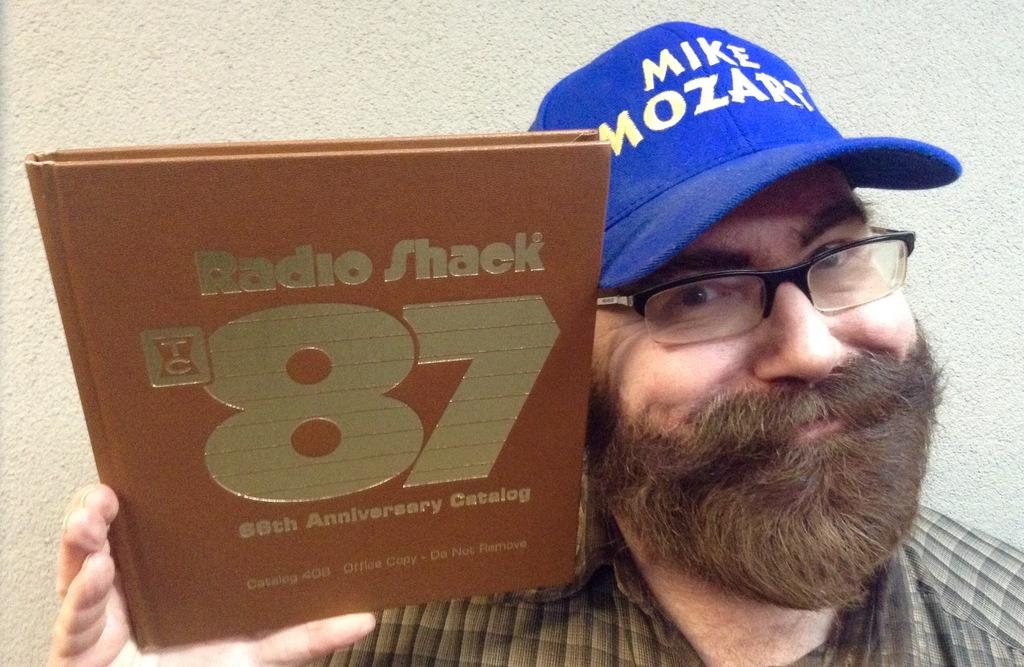Who is present in the image? There is a man in the image. What is the man holding in his hand? The man is holding a book in his hand. What type of headwear is the man wearing? The man is wearing a cap. What can be seen in the background of the image? There is a wall in the background of the image. What is the flavor of the zinc in the image? There is no zinc present in the image, and therefore no flavor can be determined. 